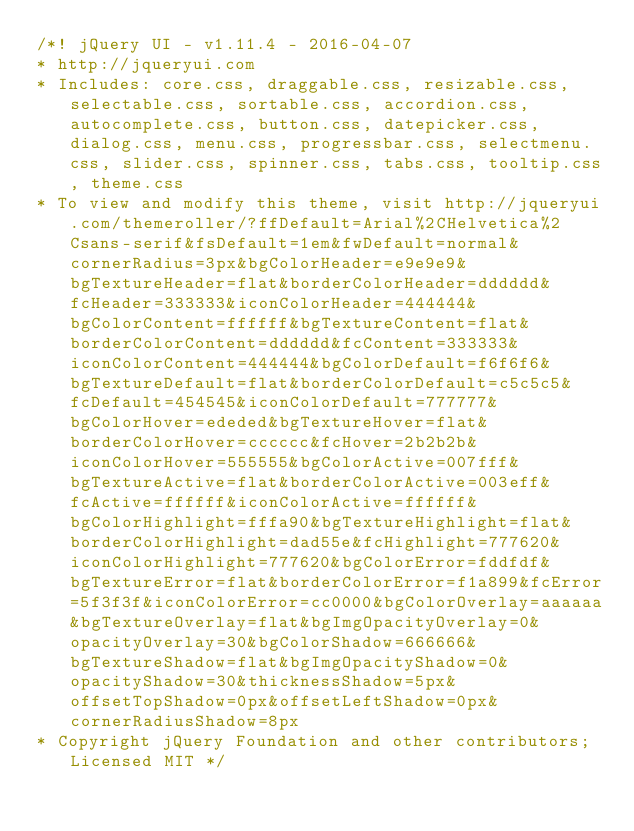<code> <loc_0><loc_0><loc_500><loc_500><_CSS_>/*! jQuery UI - v1.11.4 - 2016-04-07
* http://jqueryui.com
* Includes: core.css, draggable.css, resizable.css, selectable.css, sortable.css, accordion.css, autocomplete.css, button.css, datepicker.css, dialog.css, menu.css, progressbar.css, selectmenu.css, slider.css, spinner.css, tabs.css, tooltip.css, theme.css
* To view and modify this theme, visit http://jqueryui.com/themeroller/?ffDefault=Arial%2CHelvetica%2Csans-serif&fsDefault=1em&fwDefault=normal&cornerRadius=3px&bgColorHeader=e9e9e9&bgTextureHeader=flat&borderColorHeader=dddddd&fcHeader=333333&iconColorHeader=444444&bgColorContent=ffffff&bgTextureContent=flat&borderColorContent=dddddd&fcContent=333333&iconColorContent=444444&bgColorDefault=f6f6f6&bgTextureDefault=flat&borderColorDefault=c5c5c5&fcDefault=454545&iconColorDefault=777777&bgColorHover=ededed&bgTextureHover=flat&borderColorHover=cccccc&fcHover=2b2b2b&iconColorHover=555555&bgColorActive=007fff&bgTextureActive=flat&borderColorActive=003eff&fcActive=ffffff&iconColorActive=ffffff&bgColorHighlight=fffa90&bgTextureHighlight=flat&borderColorHighlight=dad55e&fcHighlight=777620&iconColorHighlight=777620&bgColorError=fddfdf&bgTextureError=flat&borderColorError=f1a899&fcError=5f3f3f&iconColorError=cc0000&bgColorOverlay=aaaaaa&bgTextureOverlay=flat&bgImgOpacityOverlay=0&opacityOverlay=30&bgColorShadow=666666&bgTextureShadow=flat&bgImgOpacityShadow=0&opacityShadow=30&thicknessShadow=5px&offsetTopShadow=0px&offsetLeftShadow=0px&cornerRadiusShadow=8px
* Copyright jQuery Foundation and other contributors; Licensed MIT */
</code> 